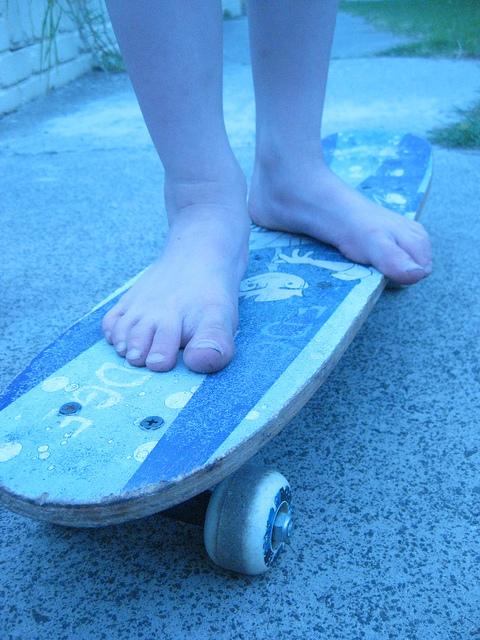How many toes are over the edge of the board?
Be succinct. 5. What is the person on?
Concise answer only. Skateboard. Is the child clean?
Short answer required. No. 